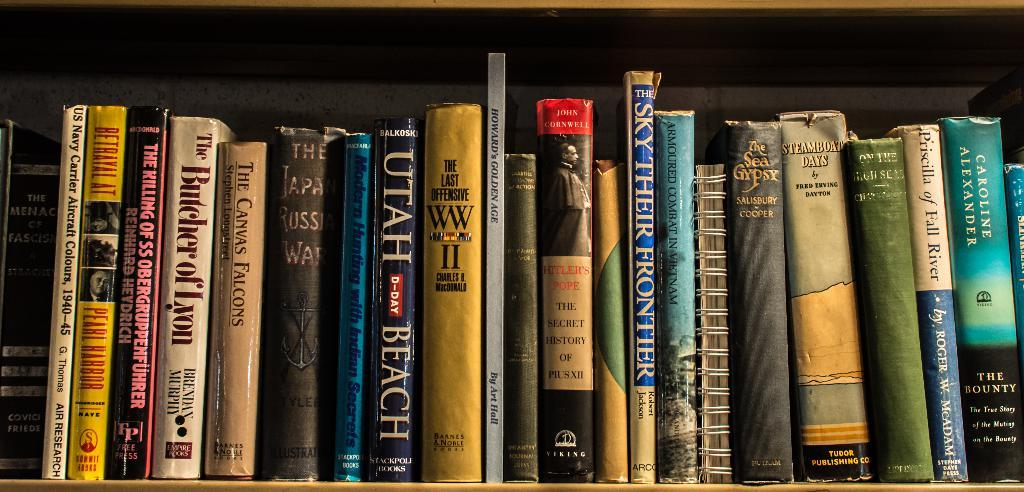<image>
Relay a brief, clear account of the picture shown. a row of books with one of them titled 'utah beach' 